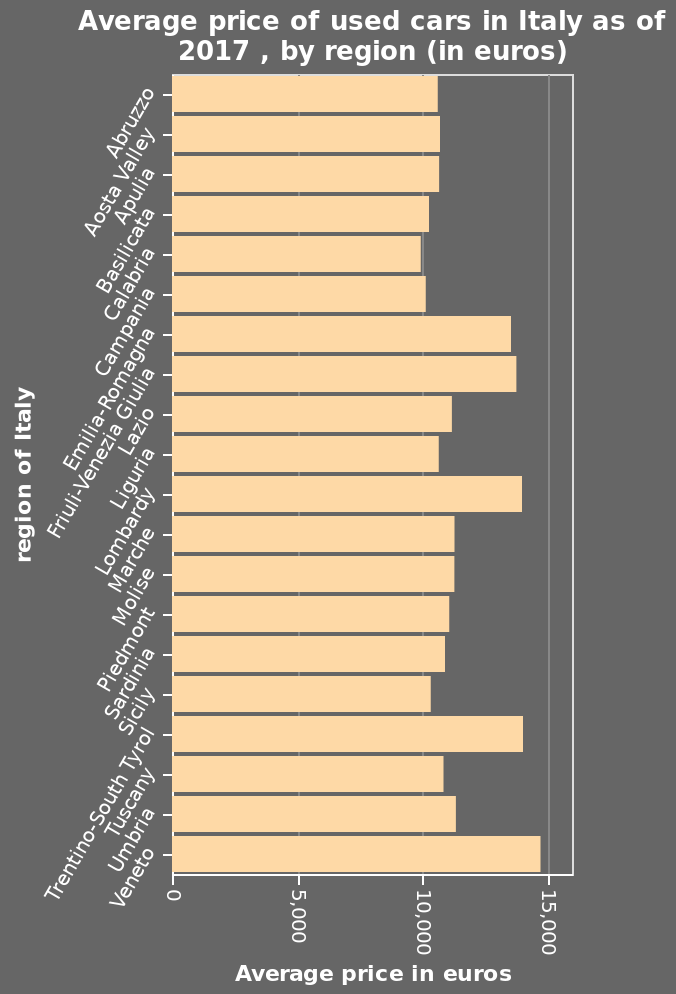<image>
What is the scale of the y-axis in the bar plot? The scale of the y-axis in the bar plot is categorical, representing the regions of Italy. Which region has the highest average price in Euros?  Veneto has the highest average price in Euros, approximately 14500. What is the range of the x-axis in the bar plot? The range of the x-axis in the bar plot is from 0 to 15,000 euros. 